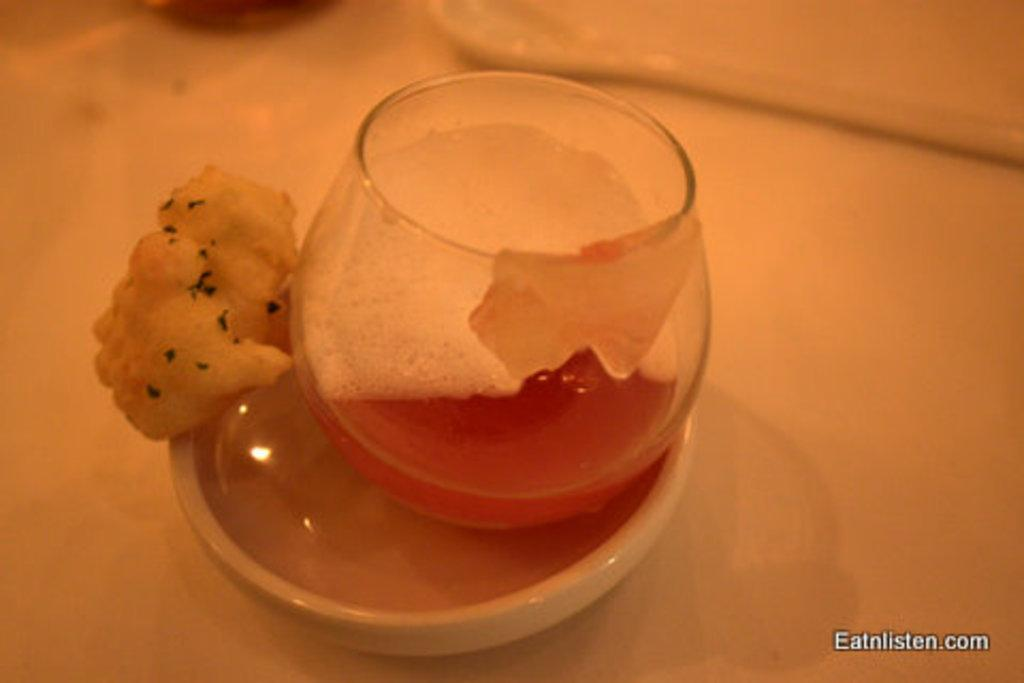What material is present in the image? There is glass in the image. What type of container is visible in the image? There is a bowl in the image. What can be found inside the bowl? There is food in the image. What is the surface on which objects are placed in the image? There are objects on a platform in the image. Where can text be found in the image? There is text in the bottom right side of the image. What type of stamp is visible on the food in the image? There is no stamp present on the food in the image. What type of badge is being worn by the glass in the image? There is no badge present on the glass in the image. 